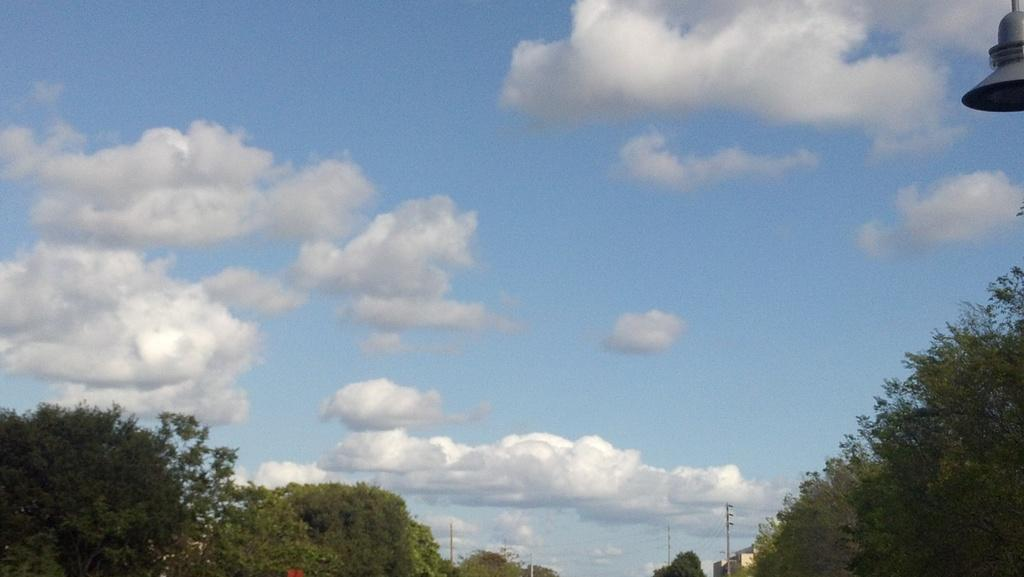What type of vegetation can be seen in the image? There are trees in the image. What else is present in the image besides trees? There are poles in the image. What can be seen in the background of the image? The sky is visible in the background of the image. How would you describe the sky in the image? The sky appears to be cloudy. Can you describe the object in the top right corner of the image? Unfortunately, the facts provided do not give enough information to describe the object in the top right corner of the image. How much dirt is visible on the ground in the image? There is no dirt visible on the ground in the image. What country is depicted in the image? The image does not depict a specific country. What type of iron is used to create the poles in the image? The facts provided do not give enough information to determine the type of iron used to create the poles in the image. 